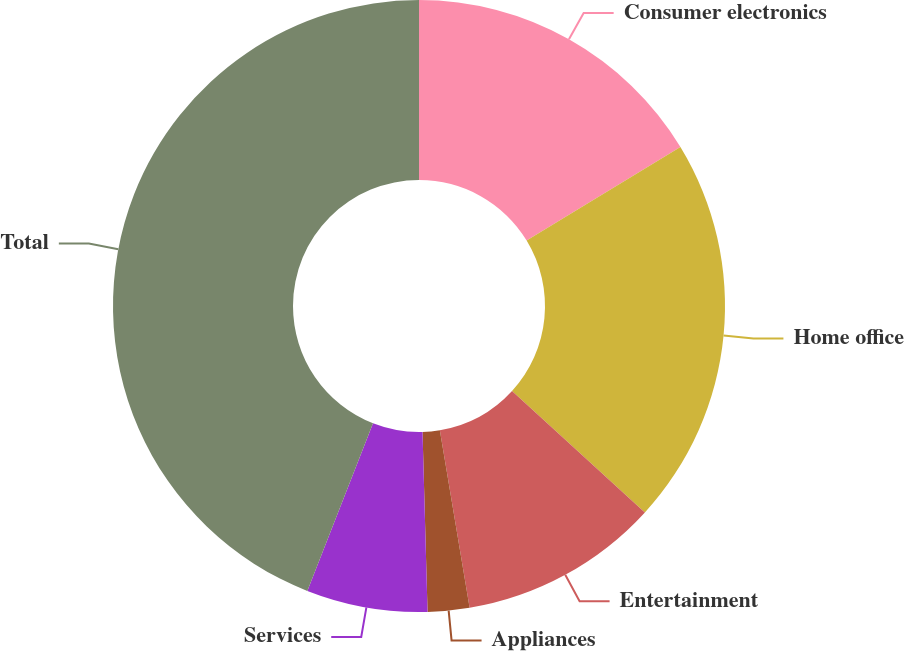<chart> <loc_0><loc_0><loc_500><loc_500><pie_chart><fcel>Consumer electronics<fcel>Home office<fcel>Entertainment<fcel>Appliances<fcel>Services<fcel>Total<nl><fcel>16.3%<fcel>20.48%<fcel>10.57%<fcel>2.2%<fcel>6.39%<fcel>44.05%<nl></chart> 